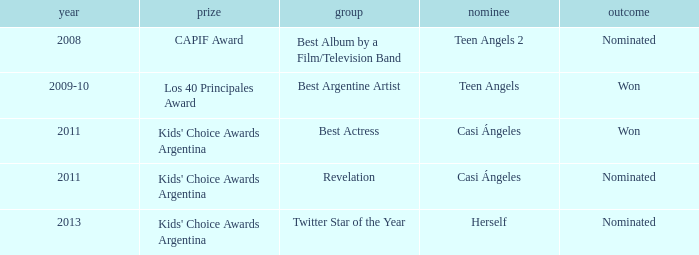What year was Teen Angels 2 nominated? 2008.0. 